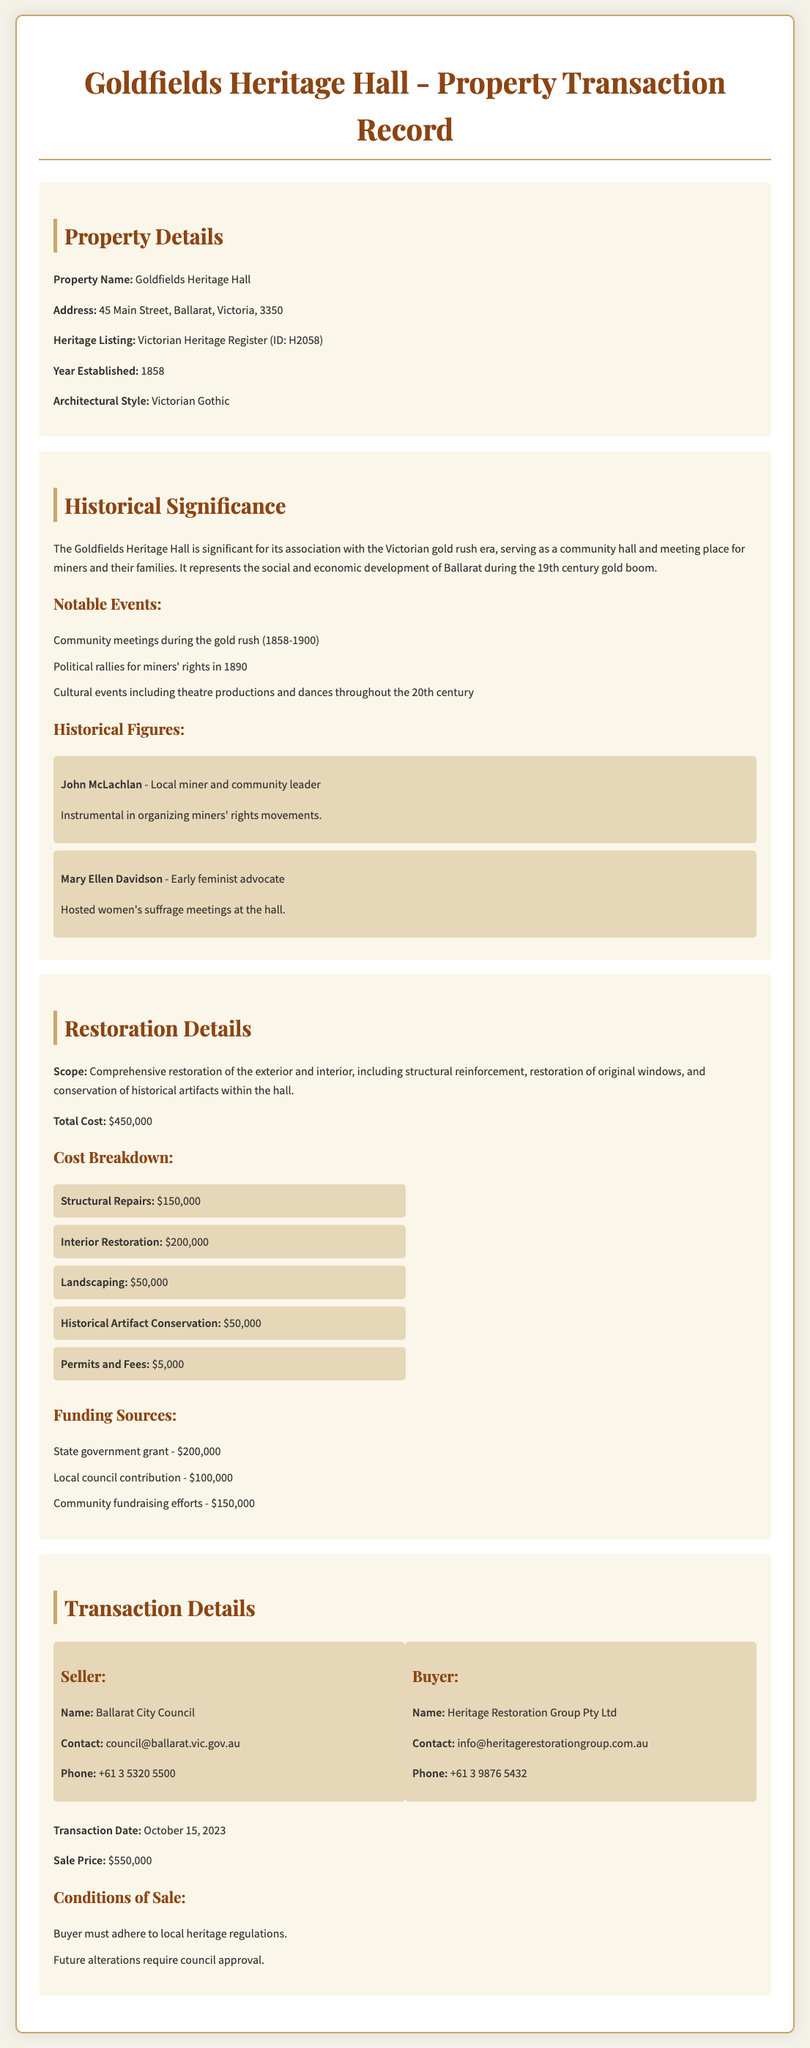What is the property name? The property name is explicitly stated in the document as "Goldfields Heritage Hall."
Answer: Goldfields Heritage Hall What is the architectural style of the building? The architectural style is specified in the property details section as "Victorian Gothic."
Answer: Victorian Gothic Who was the seller of the property? The document lists the seller as "Ballarat City Council."
Answer: Ballarat City Council What was the total cost for restoration? The total cost for restoration is mentioned in the restoration details as "$450,000."
Answer: $450,000 When was the transaction date? The transaction date is provided in the transaction details section as "October 15, 2023."
Answer: October 15, 2023 What is one notable event that took place at the Goldfields Heritage Hall? The document includes various notable events; one example is "Community meetings during the gold rush (1858-1900)."
Answer: Community meetings during the gold rush (1858-1900) How much was contributed by the state government for restoration? The document specifies that the state government grant was "$200,000."
Answer: $200,000 What are the conditions of sale regarding alterations? The conditions of sale state that "Future alterations require council approval."
Answer: Future alterations require council approval How much was spent on interior restoration? The document breaks down costs, stating that "$200,000" was allocated for interior restoration.
Answer: $200,000 